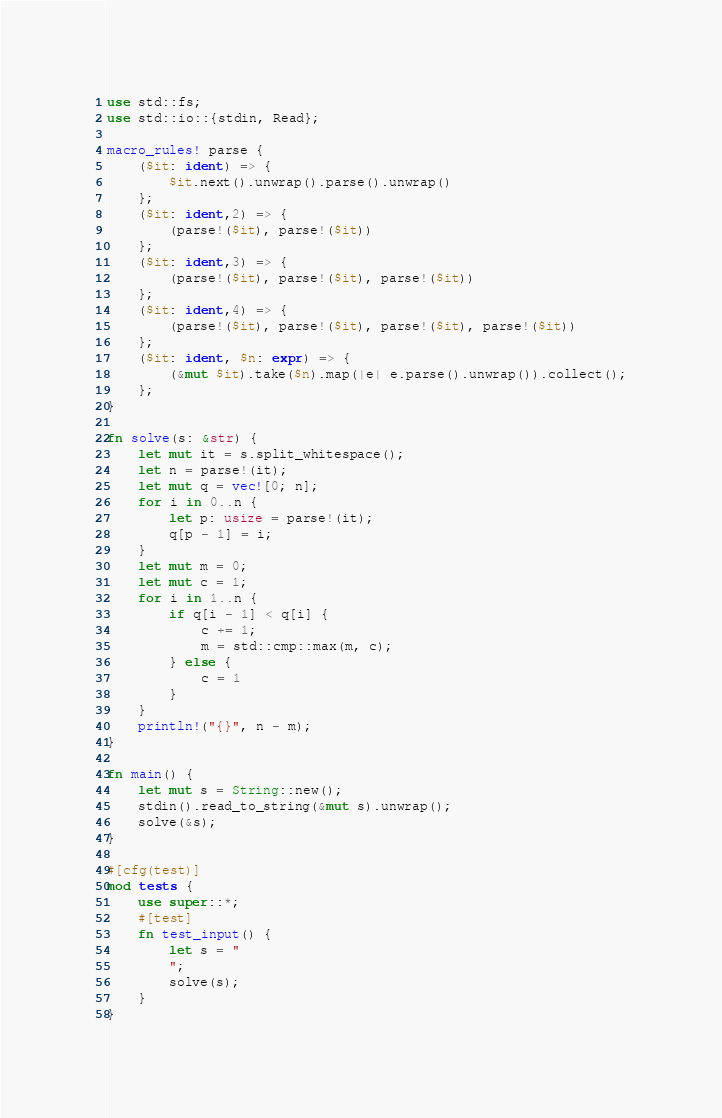Convert code to text. <code><loc_0><loc_0><loc_500><loc_500><_Rust_>use std::fs;
use std::io::{stdin, Read};

macro_rules! parse {
    ($it: ident) => {
        $it.next().unwrap().parse().unwrap()
    };
    ($it: ident,2) => {
        (parse!($it), parse!($it))
    };
    ($it: ident,3) => {
        (parse!($it), parse!($it), parse!($it))
    };
    ($it: ident,4) => {
        (parse!($it), parse!($it), parse!($it), parse!($it))
    };
    ($it: ident, $n: expr) => {
        (&mut $it).take($n).map(|e| e.parse().unwrap()).collect();
    };
}

fn solve(s: &str) {
    let mut it = s.split_whitespace();
    let n = parse!(it);
    let mut q = vec![0; n];
    for i in 0..n {
        let p: usize = parse!(it);
        q[p - 1] = i;
    }
    let mut m = 0;
    let mut c = 1;
    for i in 1..n {
        if q[i - 1] < q[i] {
            c += 1;
            m = std::cmp::max(m, c);
        } else {
            c = 1
        }
    }
    println!("{}", n - m);
}

fn main() {
    let mut s = String::new();
    stdin().read_to_string(&mut s).unwrap();
    solve(&s);
}

#[cfg(test)]
mod tests {
    use super::*;
    #[test]
    fn test_input() {
        let s = "
        ";
        solve(s);
    }
}
</code> 